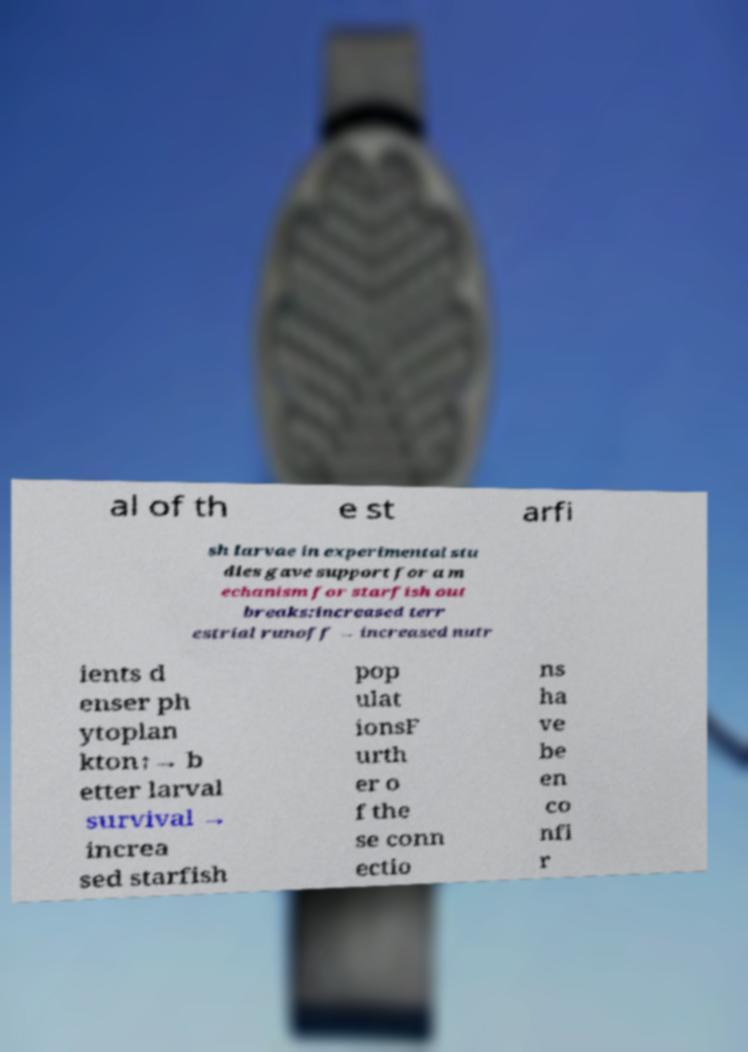Can you accurately transcribe the text from the provided image for me? al of th e st arfi sh larvae in experimental stu dies gave support for a m echanism for starfish out breaks:increased terr estrial runoff → increased nutr ients d enser ph ytoplan kton↑→ b etter larval survival → increa sed starfish pop ulat ionsF urth er o f the se conn ectio ns ha ve be en co nfi r 